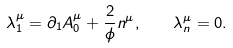<formula> <loc_0><loc_0><loc_500><loc_500>\lambda ^ { \mu } _ { 1 } = \partial _ { 1 } A ^ { \mu } _ { 0 } + \frac { 2 } { \phi } n ^ { \mu } , \quad \lambda ^ { \mu } _ { n } = 0 .</formula> 